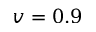<formula> <loc_0><loc_0><loc_500><loc_500>v = 0 . 9</formula> 